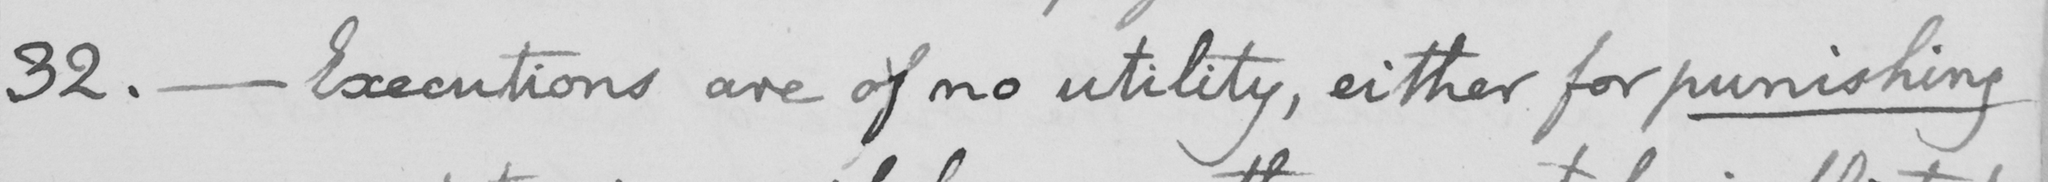Can you tell me what this handwritten text says? 32. _ Executions are of no utility, either for punishing 